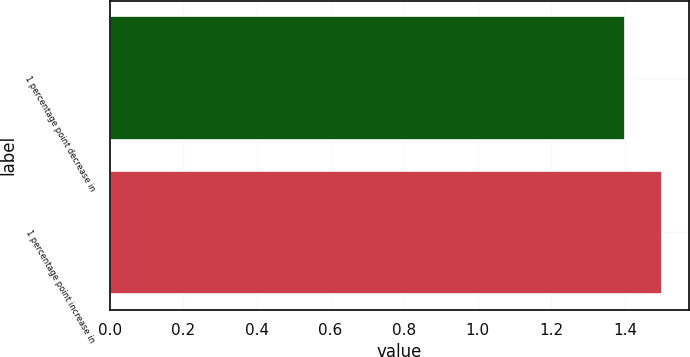<chart> <loc_0><loc_0><loc_500><loc_500><bar_chart><fcel>1 percentage point decrease in<fcel>1 percentage point increase in<nl><fcel>1.4<fcel>1.5<nl></chart> 